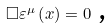<formula> <loc_0><loc_0><loc_500><loc_500>\Box \varepsilon ^ { \mu } \left ( x \right ) = 0 \text { ,}</formula> 